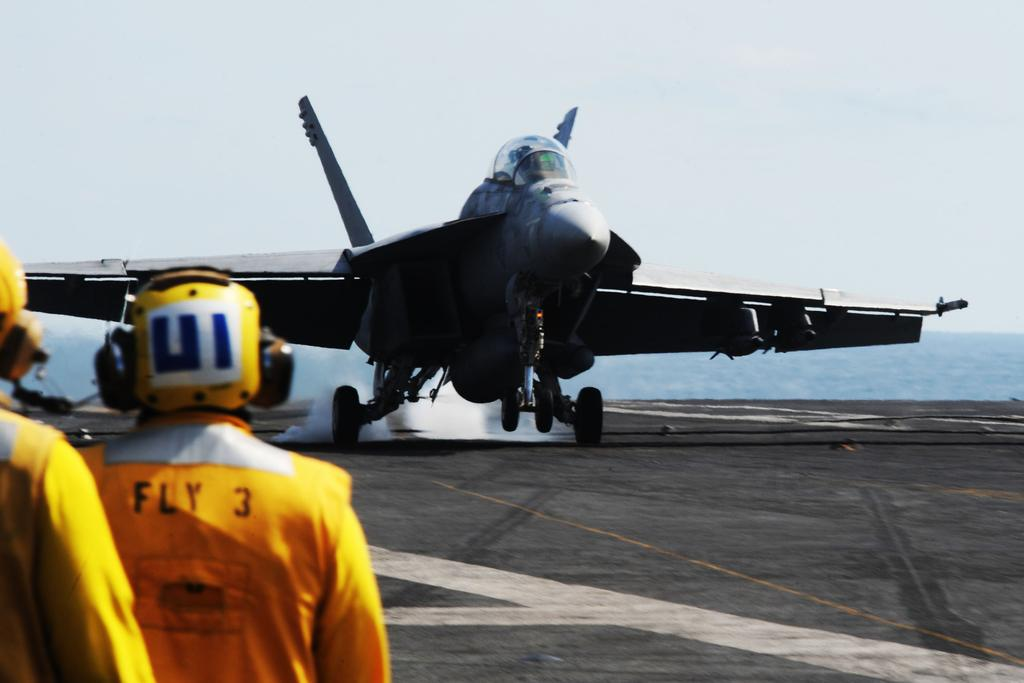<image>
Share a concise interpretation of the image provided. A person in an orange suit with Fly 3 on the back stands in front of a fighter jet. 